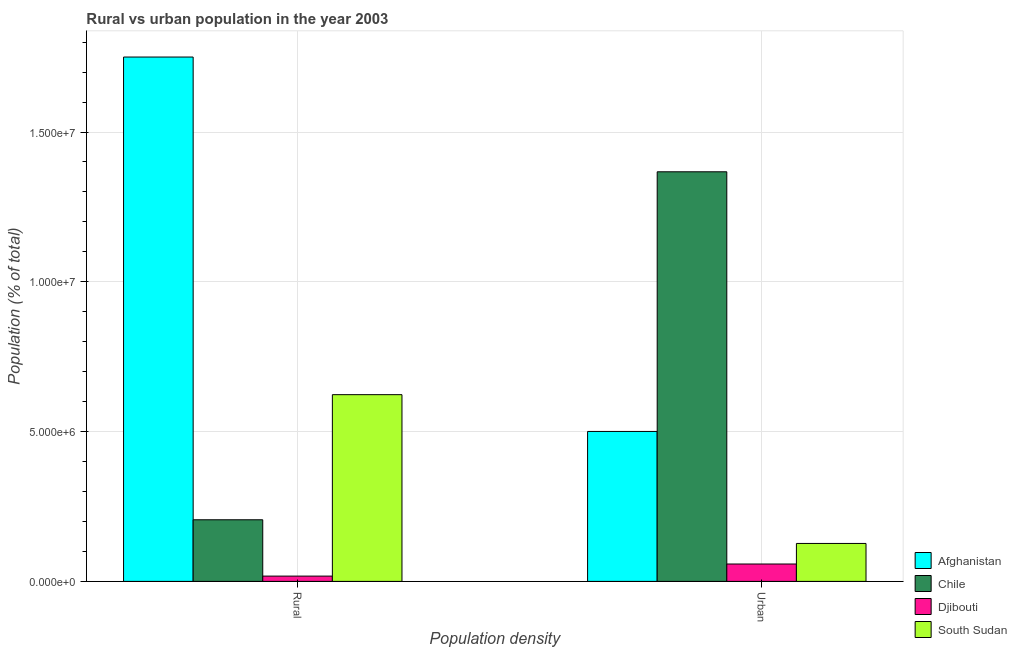How many groups of bars are there?
Ensure brevity in your answer.  2. Are the number of bars per tick equal to the number of legend labels?
Make the answer very short. Yes. What is the label of the 1st group of bars from the left?
Keep it short and to the point. Rural. What is the urban population density in Afghanistan?
Offer a very short reply. 5.00e+06. Across all countries, what is the maximum urban population density?
Ensure brevity in your answer.  1.37e+07. Across all countries, what is the minimum rural population density?
Provide a short and direct response. 1.77e+05. In which country was the urban population density minimum?
Offer a terse response. Djibouti. What is the total rural population density in the graph?
Your response must be concise. 2.60e+07. What is the difference between the urban population density in Djibouti and that in Chile?
Your response must be concise. -1.31e+07. What is the difference between the urban population density in South Sudan and the rural population density in Chile?
Offer a terse response. -7.90e+05. What is the average rural population density per country?
Make the answer very short. 6.49e+06. What is the difference between the rural population density and urban population density in Djibouti?
Ensure brevity in your answer.  -4.04e+05. In how many countries, is the urban population density greater than 12000000 %?
Give a very brief answer. 1. What is the ratio of the rural population density in Chile to that in Djibouti?
Your response must be concise. 11.65. What does the 1st bar from the left in Rural represents?
Your answer should be very brief. Afghanistan. How many bars are there?
Offer a very short reply. 8. Are all the bars in the graph horizontal?
Provide a short and direct response. No. Does the graph contain grids?
Ensure brevity in your answer.  Yes. Where does the legend appear in the graph?
Keep it short and to the point. Bottom right. How are the legend labels stacked?
Your answer should be compact. Vertical. What is the title of the graph?
Offer a very short reply. Rural vs urban population in the year 2003. Does "Iceland" appear as one of the legend labels in the graph?
Offer a terse response. No. What is the label or title of the X-axis?
Offer a terse response. Population density. What is the label or title of the Y-axis?
Make the answer very short. Population (% of total). What is the Population (% of total) in Afghanistan in Rural?
Your answer should be very brief. 1.75e+07. What is the Population (% of total) in Chile in Rural?
Your answer should be very brief. 2.06e+06. What is the Population (% of total) in Djibouti in Rural?
Your response must be concise. 1.77e+05. What is the Population (% of total) of South Sudan in Rural?
Provide a succinct answer. 6.23e+06. What is the Population (% of total) of Afghanistan in Urban?
Offer a terse response. 5.00e+06. What is the Population (% of total) in Chile in Urban?
Your answer should be very brief. 1.37e+07. What is the Population (% of total) in Djibouti in Urban?
Your answer should be compact. 5.80e+05. What is the Population (% of total) in South Sudan in Urban?
Offer a very short reply. 1.27e+06. Across all Population density, what is the maximum Population (% of total) in Afghanistan?
Keep it short and to the point. 1.75e+07. Across all Population density, what is the maximum Population (% of total) of Chile?
Your response must be concise. 1.37e+07. Across all Population density, what is the maximum Population (% of total) of Djibouti?
Keep it short and to the point. 5.80e+05. Across all Population density, what is the maximum Population (% of total) in South Sudan?
Keep it short and to the point. 6.23e+06. Across all Population density, what is the minimum Population (% of total) of Afghanistan?
Ensure brevity in your answer.  5.00e+06. Across all Population density, what is the minimum Population (% of total) in Chile?
Offer a terse response. 2.06e+06. Across all Population density, what is the minimum Population (% of total) in Djibouti?
Give a very brief answer. 1.77e+05. Across all Population density, what is the minimum Population (% of total) of South Sudan?
Your answer should be compact. 1.27e+06. What is the total Population (% of total) in Afghanistan in the graph?
Your answer should be very brief. 2.25e+07. What is the total Population (% of total) of Chile in the graph?
Your answer should be compact. 1.57e+07. What is the total Population (% of total) in Djibouti in the graph?
Offer a terse response. 7.57e+05. What is the total Population (% of total) in South Sudan in the graph?
Give a very brief answer. 7.50e+06. What is the difference between the Population (% of total) in Afghanistan in Rural and that in Urban?
Make the answer very short. 1.25e+07. What is the difference between the Population (% of total) in Chile in Rural and that in Urban?
Provide a succinct answer. -1.16e+07. What is the difference between the Population (% of total) of Djibouti in Rural and that in Urban?
Provide a succinct answer. -4.04e+05. What is the difference between the Population (% of total) of South Sudan in Rural and that in Urban?
Your response must be concise. 4.97e+06. What is the difference between the Population (% of total) of Afghanistan in Rural and the Population (% of total) of Chile in Urban?
Your response must be concise. 3.83e+06. What is the difference between the Population (% of total) of Afghanistan in Rural and the Population (% of total) of Djibouti in Urban?
Your answer should be compact. 1.69e+07. What is the difference between the Population (% of total) in Afghanistan in Rural and the Population (% of total) in South Sudan in Urban?
Your answer should be compact. 1.62e+07. What is the difference between the Population (% of total) in Chile in Rural and the Population (% of total) in Djibouti in Urban?
Make the answer very short. 1.48e+06. What is the difference between the Population (% of total) in Chile in Rural and the Population (% of total) in South Sudan in Urban?
Ensure brevity in your answer.  7.90e+05. What is the difference between the Population (% of total) in Djibouti in Rural and the Population (% of total) in South Sudan in Urban?
Keep it short and to the point. -1.09e+06. What is the average Population (% of total) of Afghanistan per Population density?
Your answer should be compact. 1.13e+07. What is the average Population (% of total) of Chile per Population density?
Your response must be concise. 7.86e+06. What is the average Population (% of total) in Djibouti per Population density?
Make the answer very short. 3.78e+05. What is the average Population (% of total) in South Sudan per Population density?
Keep it short and to the point. 3.75e+06. What is the difference between the Population (% of total) in Afghanistan and Population (% of total) in Chile in Rural?
Provide a short and direct response. 1.54e+07. What is the difference between the Population (% of total) of Afghanistan and Population (% of total) of Djibouti in Rural?
Provide a short and direct response. 1.73e+07. What is the difference between the Population (% of total) of Afghanistan and Population (% of total) of South Sudan in Rural?
Provide a short and direct response. 1.13e+07. What is the difference between the Population (% of total) in Chile and Population (% of total) in Djibouti in Rural?
Offer a very short reply. 1.88e+06. What is the difference between the Population (% of total) in Chile and Population (% of total) in South Sudan in Rural?
Give a very brief answer. -4.18e+06. What is the difference between the Population (% of total) of Djibouti and Population (% of total) of South Sudan in Rural?
Ensure brevity in your answer.  -6.06e+06. What is the difference between the Population (% of total) in Afghanistan and Population (% of total) in Chile in Urban?
Provide a short and direct response. -8.67e+06. What is the difference between the Population (% of total) in Afghanistan and Population (% of total) in Djibouti in Urban?
Give a very brief answer. 4.42e+06. What is the difference between the Population (% of total) in Afghanistan and Population (% of total) in South Sudan in Urban?
Keep it short and to the point. 3.74e+06. What is the difference between the Population (% of total) in Chile and Population (% of total) in Djibouti in Urban?
Ensure brevity in your answer.  1.31e+07. What is the difference between the Population (% of total) of Chile and Population (% of total) of South Sudan in Urban?
Your response must be concise. 1.24e+07. What is the difference between the Population (% of total) of Djibouti and Population (% of total) of South Sudan in Urban?
Your response must be concise. -6.87e+05. What is the ratio of the Population (% of total) of Afghanistan in Rural to that in Urban?
Ensure brevity in your answer.  3.5. What is the ratio of the Population (% of total) in Chile in Rural to that in Urban?
Your answer should be very brief. 0.15. What is the ratio of the Population (% of total) in Djibouti in Rural to that in Urban?
Provide a succinct answer. 0.3. What is the ratio of the Population (% of total) in South Sudan in Rural to that in Urban?
Ensure brevity in your answer.  4.92. What is the difference between the highest and the second highest Population (% of total) of Afghanistan?
Your answer should be compact. 1.25e+07. What is the difference between the highest and the second highest Population (% of total) in Chile?
Your answer should be compact. 1.16e+07. What is the difference between the highest and the second highest Population (% of total) in Djibouti?
Make the answer very short. 4.04e+05. What is the difference between the highest and the second highest Population (% of total) in South Sudan?
Ensure brevity in your answer.  4.97e+06. What is the difference between the highest and the lowest Population (% of total) of Afghanistan?
Your answer should be compact. 1.25e+07. What is the difference between the highest and the lowest Population (% of total) in Chile?
Ensure brevity in your answer.  1.16e+07. What is the difference between the highest and the lowest Population (% of total) of Djibouti?
Offer a terse response. 4.04e+05. What is the difference between the highest and the lowest Population (% of total) of South Sudan?
Offer a very short reply. 4.97e+06. 